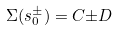<formula> <loc_0><loc_0><loc_500><loc_500>\Sigma ( s ^ { \pm } _ { 0 } ) = C { \pm } D</formula> 